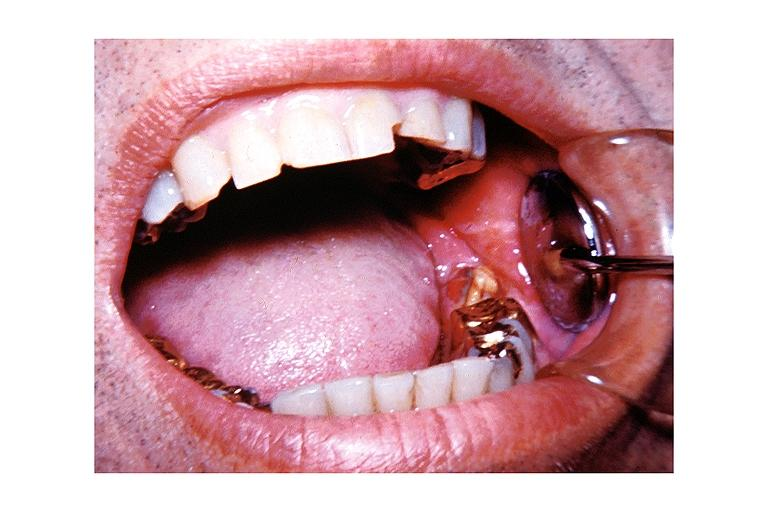where is this?
Answer the question using a single word or phrase. Oral 